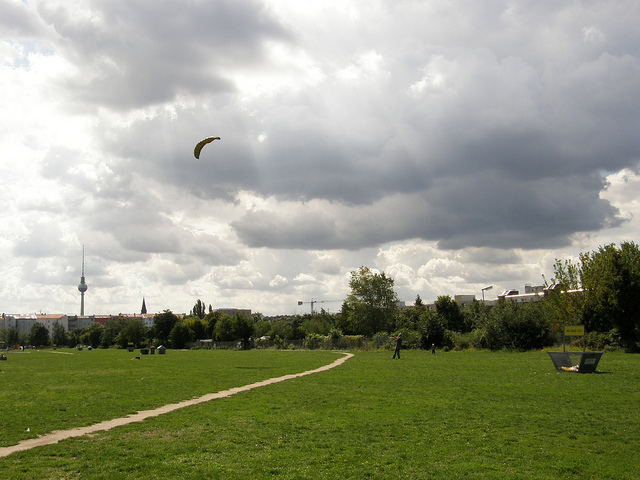<image>What is the large tower off in the distance? The large tower off in the distance is unknown. It might be a water tower, space needle, building, or lighthouse. What is the large tower off in the distance? I don't know which tower is being referred to as the "large tower off in the distance". It could be a water tower, a space needle, a building, a lighthouse, or an antenna. 